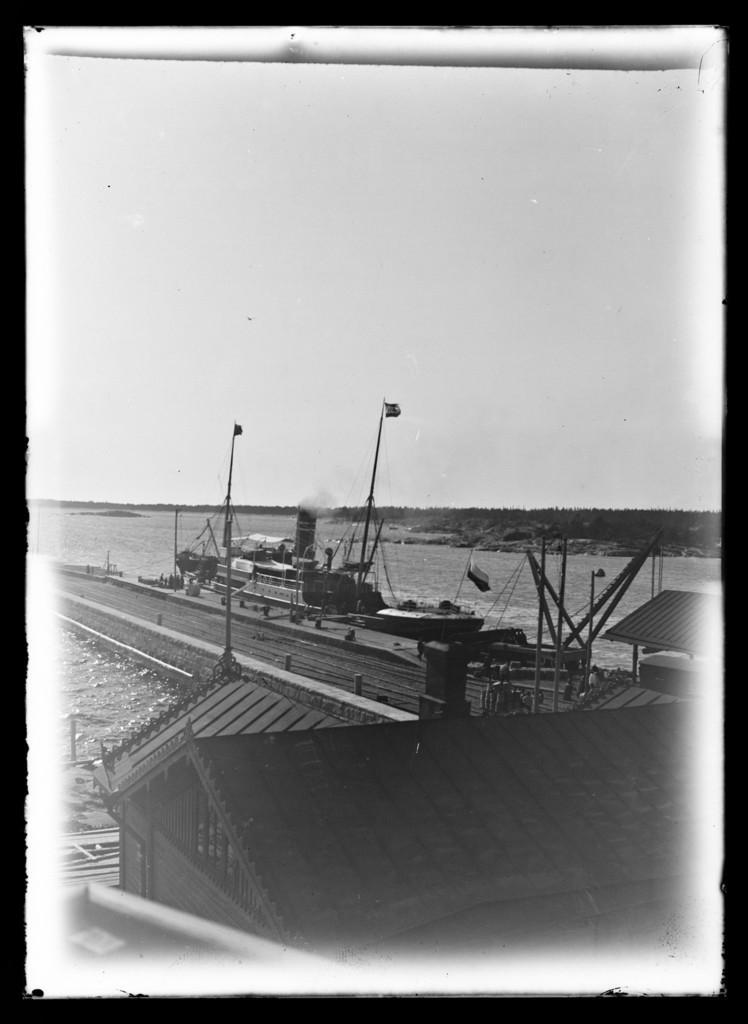Can you describe this image briefly? In this picture I can see there is a building at the bottom, there is a bridge, a yacht and there are trees in the backdrop and the sky is clear. This is a black and white picture. 